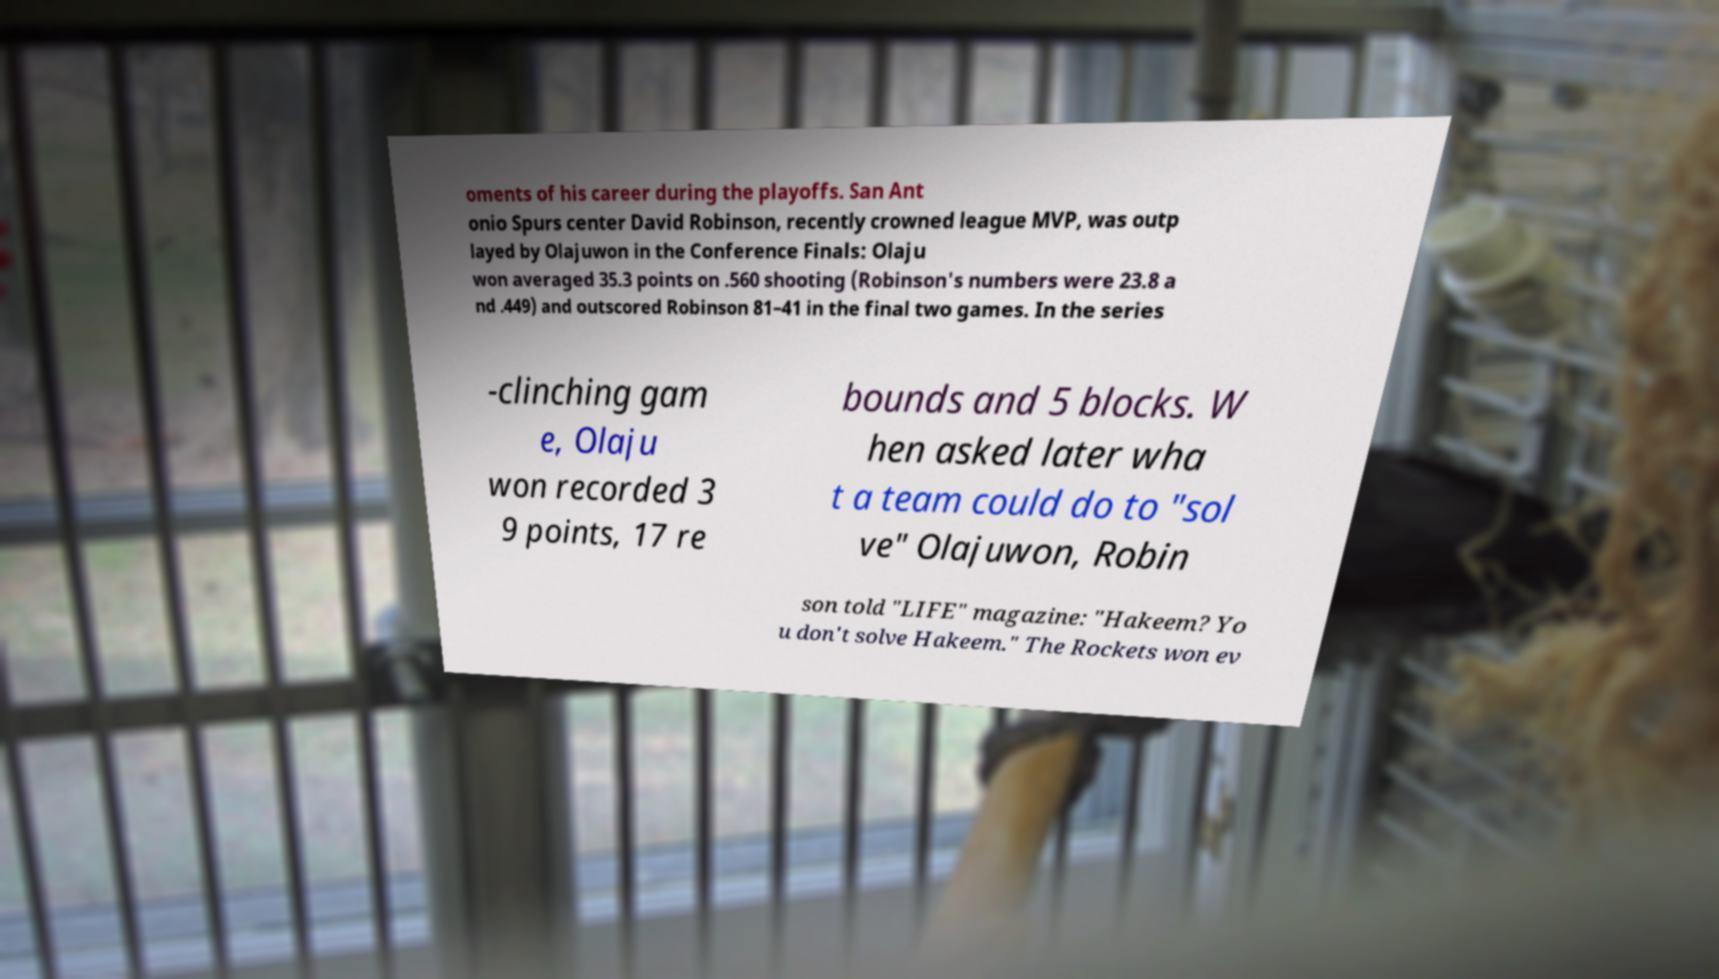Please read and relay the text visible in this image. What does it say? oments of his career during the playoffs. San Ant onio Spurs center David Robinson, recently crowned league MVP, was outp layed by Olajuwon in the Conference Finals: Olaju won averaged 35.3 points on .560 shooting (Robinson's numbers were 23.8 a nd .449) and outscored Robinson 81–41 in the final two games. In the series -clinching gam e, Olaju won recorded 3 9 points, 17 re bounds and 5 blocks. W hen asked later wha t a team could do to "sol ve" Olajuwon, Robin son told "LIFE" magazine: "Hakeem? Yo u don't solve Hakeem." The Rockets won ev 